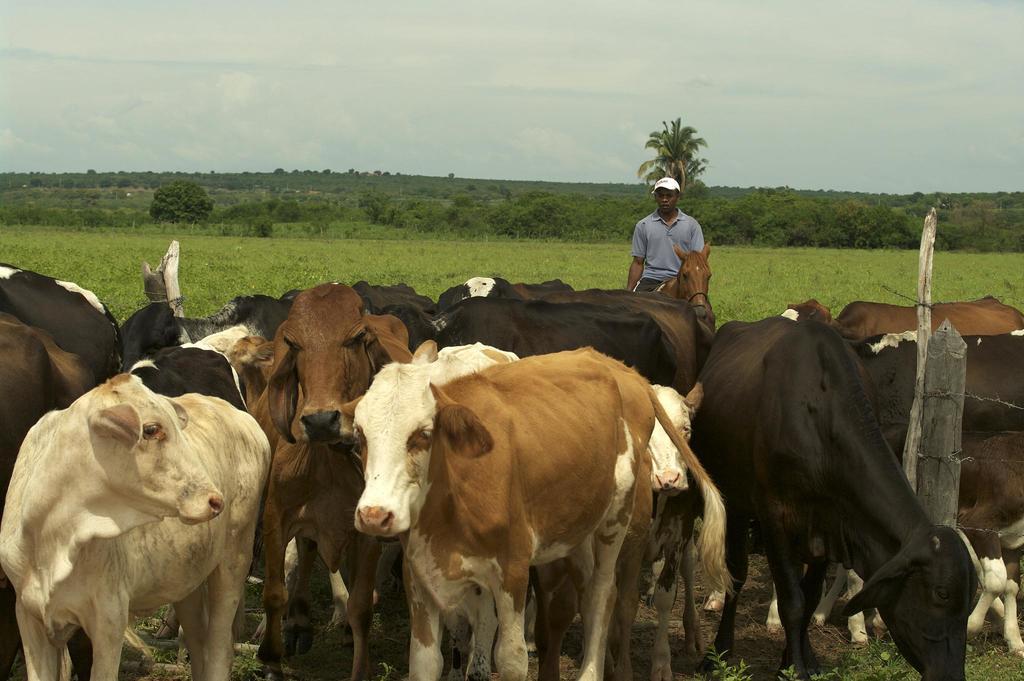Can you describe this image briefly? In the center of the image we can see cows and a horse. There is a man standing. In the background there are trees and sky. We can see a fence. 